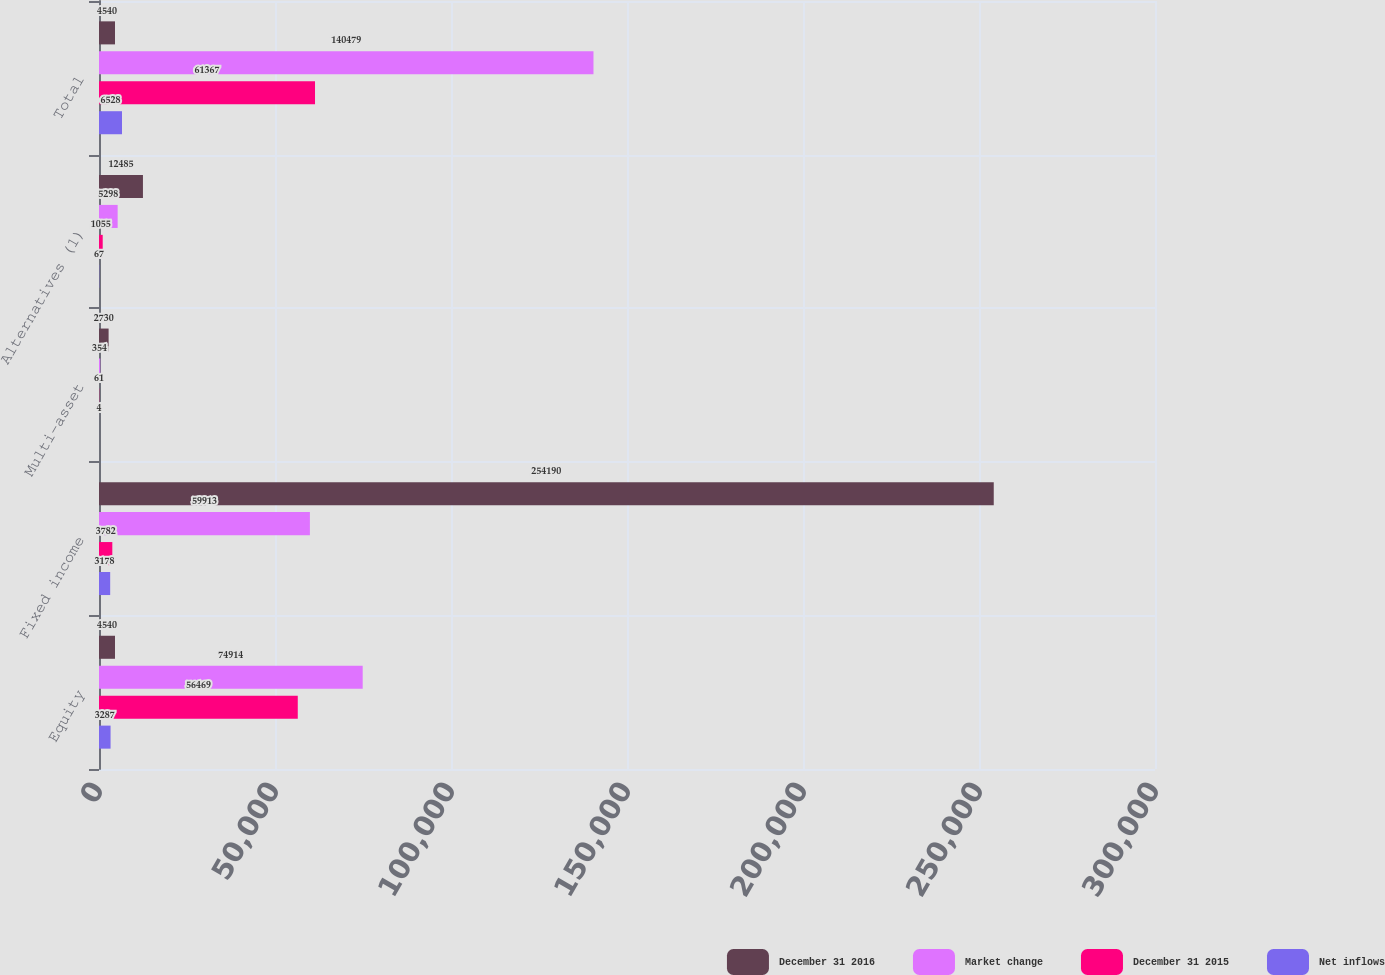<chart> <loc_0><loc_0><loc_500><loc_500><stacked_bar_chart><ecel><fcel>Equity<fcel>Fixed income<fcel>Multi-asset<fcel>Alternatives (1)<fcel>Total<nl><fcel>December 31 2016<fcel>4540<fcel>254190<fcel>2730<fcel>12485<fcel>4540<nl><fcel>Market change<fcel>74914<fcel>59913<fcel>354<fcel>5298<fcel>140479<nl><fcel>December 31 2015<fcel>56469<fcel>3782<fcel>61<fcel>1055<fcel>61367<nl><fcel>Net inflows<fcel>3287<fcel>3178<fcel>4<fcel>67<fcel>6528<nl></chart> 